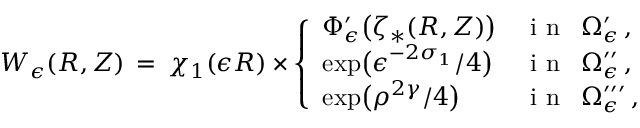Convert formula to latex. <formula><loc_0><loc_0><loc_500><loc_500>W _ { \epsilon } ( R , Z ) \, = \, \chi _ { 1 } ( \epsilon R ) \times \left \{ \begin{array} { l l } { \Phi _ { \epsilon } ^ { \prime } \left ( \zeta _ { * } ( R , Z ) \right ) } & { i n \, \Omega _ { \epsilon } ^ { \prime } \, , } \\ { \exp \left ( \epsilon ^ { - 2 \sigma _ { 1 } } / 4 \right ) } & { i n \, \Omega _ { \epsilon } ^ { \prime \prime } \, , } \\ { \exp \left ( \rho ^ { 2 \gamma } / 4 \right ) } & { i n \, \Omega _ { \epsilon } ^ { \prime \prime \prime } \, , } \end{array}</formula> 